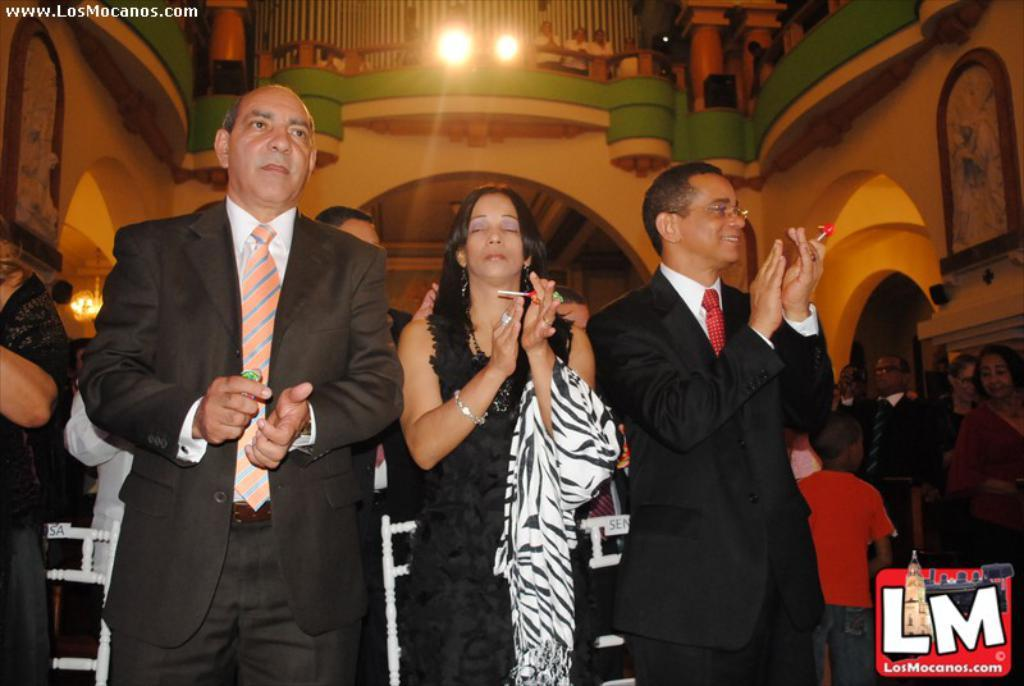What is happening with the group of people in the image? The people in the image are holding objects and clapping their hands. What can be seen on the walls in the background? There are paintings on the walls in the background. What is happening with the people behind the balcony in the background? There are people standing behind a balcony in the background. What type of salt can be seen on the people's lips in the image? There is no salt or mention of lips in the image; the people are clapping their hands and holding objects. 